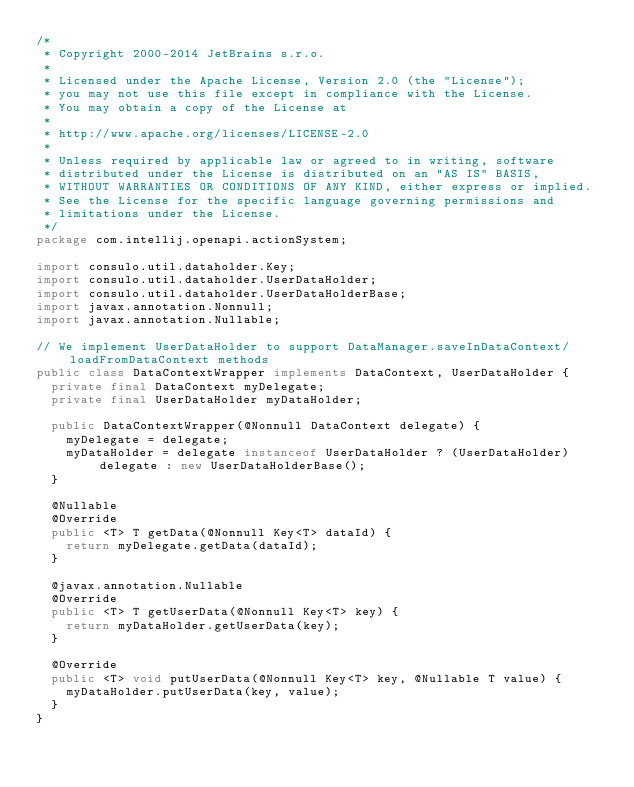Convert code to text. <code><loc_0><loc_0><loc_500><loc_500><_Java_>/*
 * Copyright 2000-2014 JetBrains s.r.o.
 *
 * Licensed under the Apache License, Version 2.0 (the "License");
 * you may not use this file except in compliance with the License.
 * You may obtain a copy of the License at
 *
 * http://www.apache.org/licenses/LICENSE-2.0
 *
 * Unless required by applicable law or agreed to in writing, software
 * distributed under the License is distributed on an "AS IS" BASIS,
 * WITHOUT WARRANTIES OR CONDITIONS OF ANY KIND, either express or implied.
 * See the License for the specific language governing permissions and
 * limitations under the License.
 */
package com.intellij.openapi.actionSystem;

import consulo.util.dataholder.Key;
import consulo.util.dataholder.UserDataHolder;
import consulo.util.dataholder.UserDataHolderBase;
import javax.annotation.Nonnull;
import javax.annotation.Nullable;

// We implement UserDataHolder to support DataManager.saveInDataContext/loadFromDataContext methods
public class DataContextWrapper implements DataContext, UserDataHolder {
  private final DataContext myDelegate;
  private final UserDataHolder myDataHolder;

  public DataContextWrapper(@Nonnull DataContext delegate) {
    myDelegate = delegate;
    myDataHolder = delegate instanceof UserDataHolder ? (UserDataHolder) delegate : new UserDataHolderBase();
  }

  @Nullable
  @Override
  public <T> T getData(@Nonnull Key<T> dataId) {
    return myDelegate.getData(dataId);
  }

  @javax.annotation.Nullable
  @Override
  public <T> T getUserData(@Nonnull Key<T> key) {
    return myDataHolder.getUserData(key);
  }

  @Override
  public <T> void putUserData(@Nonnull Key<T> key, @Nullable T value) {
    myDataHolder.putUserData(key, value);
  }
}
</code> 